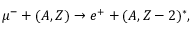Convert formula to latex. <formula><loc_0><loc_0><loc_500><loc_500>\mu ^ { - } + ( A , Z ) \rightarrow e ^ { + } + ( A , Z - 2 ) ^ { * } ,</formula> 